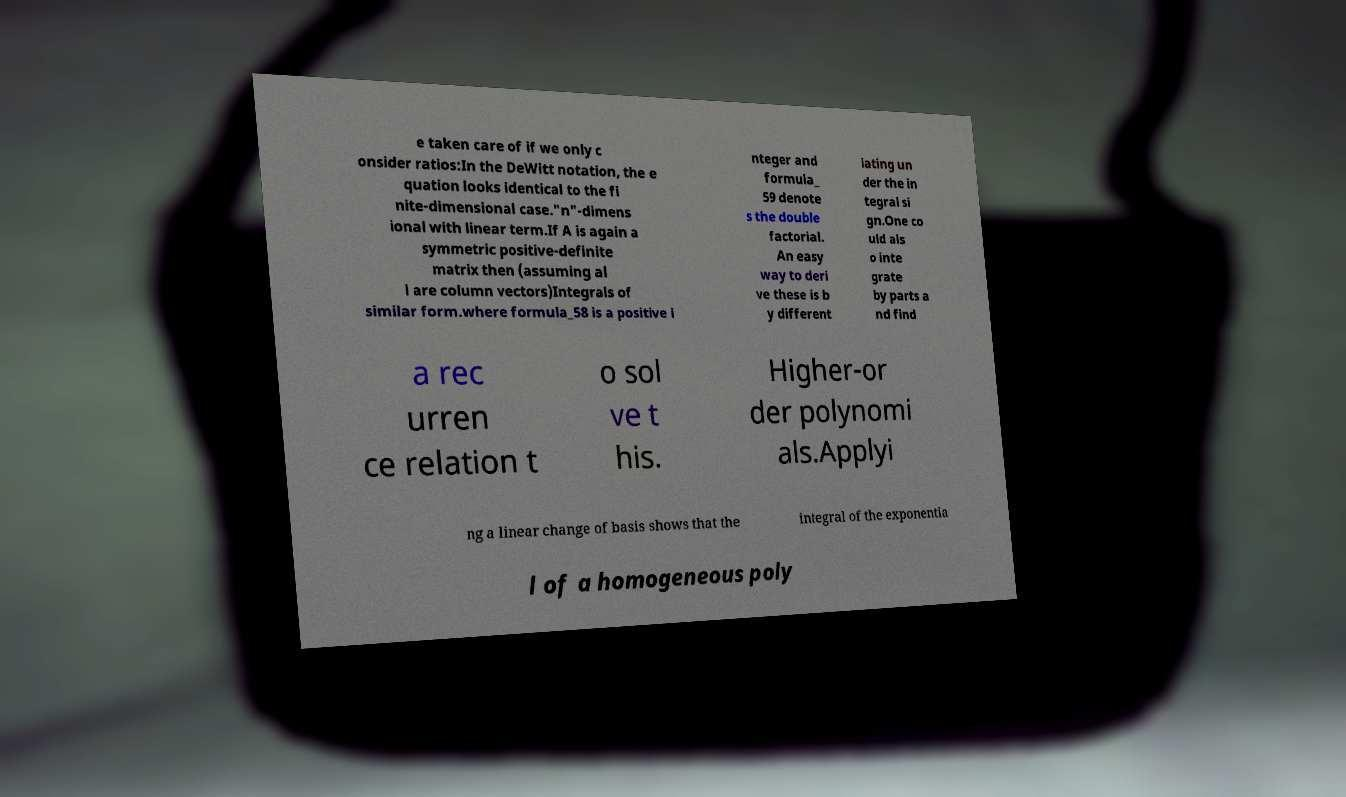Can you accurately transcribe the text from the provided image for me? e taken care of if we only c onsider ratios:In the DeWitt notation, the e quation looks identical to the fi nite-dimensional case."n"-dimens ional with linear term.If A is again a symmetric positive-definite matrix then (assuming al l are column vectors)Integrals of similar form.where formula_58 is a positive i nteger and formula_ 59 denote s the double factorial. An easy way to deri ve these is b y different iating un der the in tegral si gn.One co uld als o inte grate by parts a nd find a rec urren ce relation t o sol ve t his. Higher-or der polynomi als.Applyi ng a linear change of basis shows that the integral of the exponentia l of a homogeneous poly 